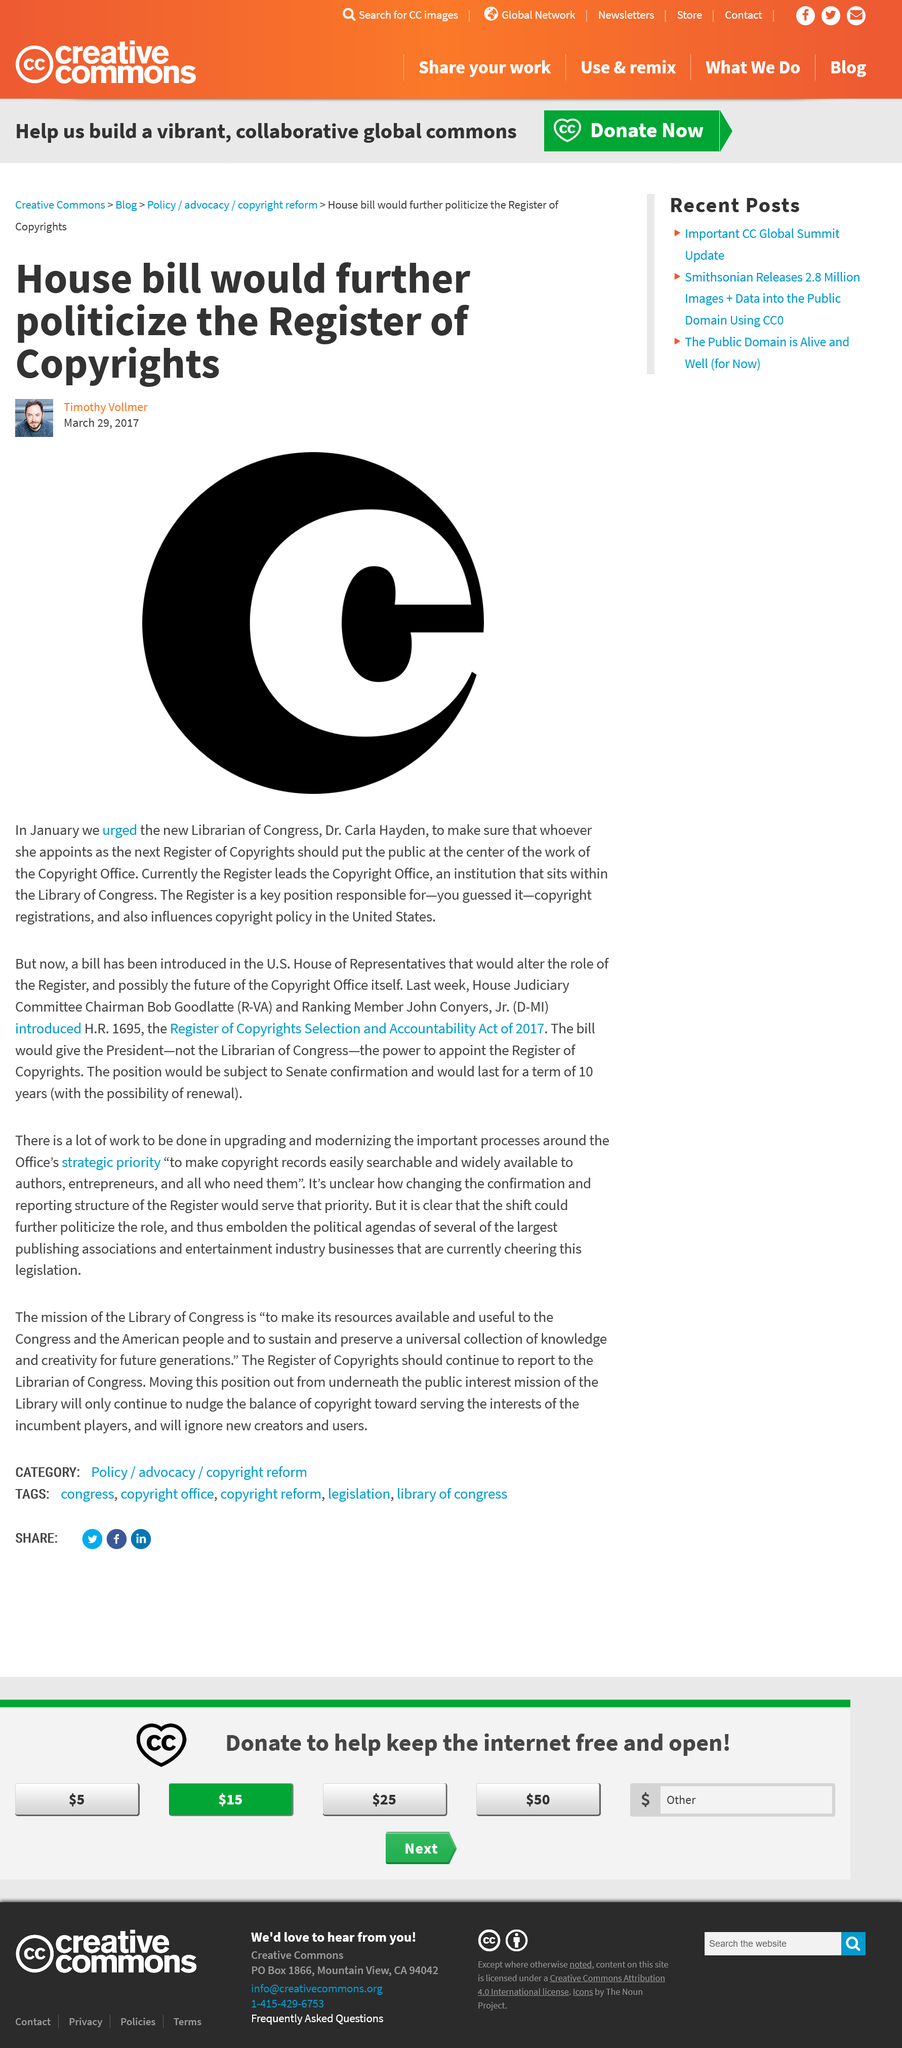Outline some significant characteristics in this image. The position of Register of Copyrights is not an elected one, but rather, it is appointed by the Librarian of Congress. The Copyright Office is located within the United States Library of Congress. The author Timothy Vollmer advocated that the Register of Copyrights should prioritize the interests of the public in the work of the Copyright Office, as evidenced by his March 29, 2017 article. 